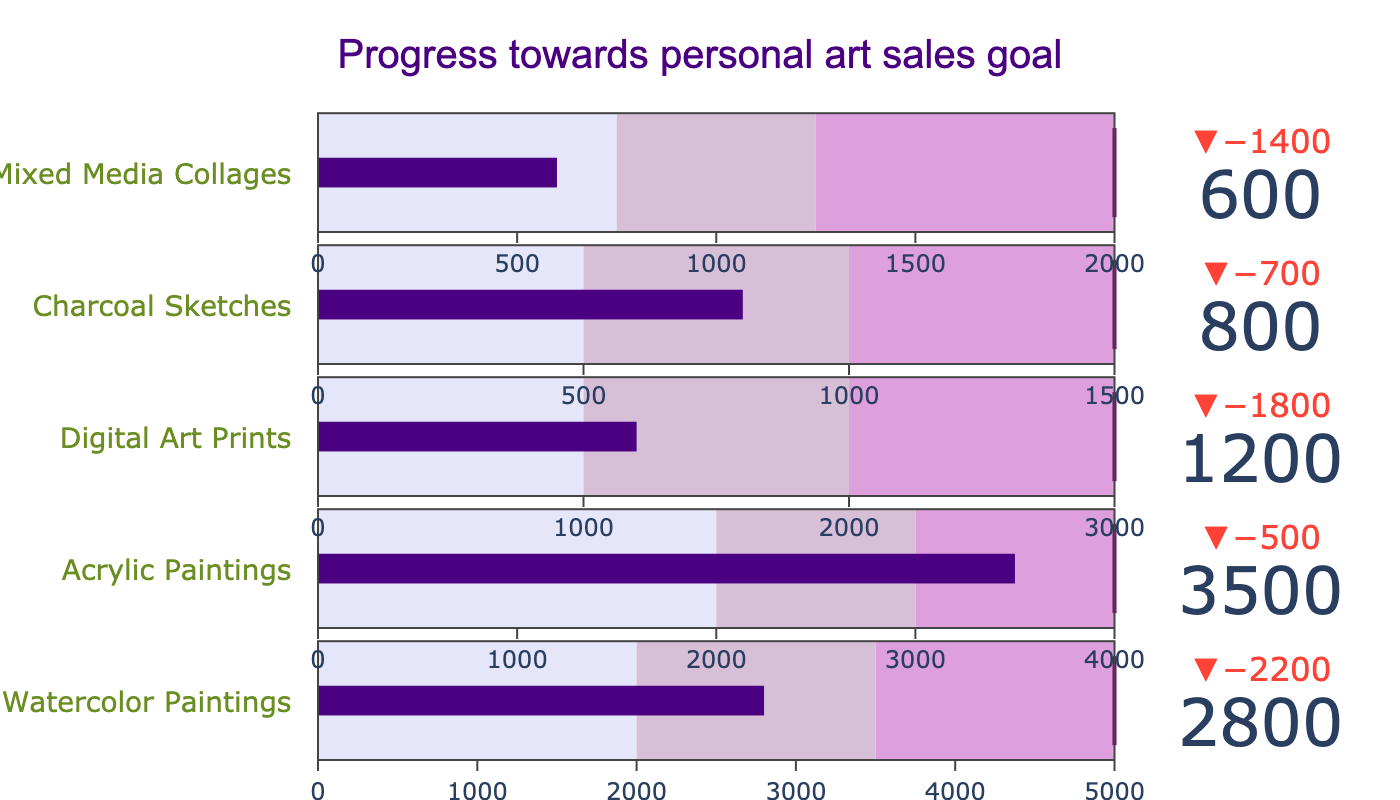How many types of art mediums are displayed in the figure? By observing the titles for each row, we can count the number of different art mediums listed in the chart.
Answer: 5 What is the title of the chart? The title of the chart is displayed at the top center of the figure.
Answer: Progress towards personal art sales goal Which art medium has the highest actual sales value? By comparing the actual sales values for each art medium, we see which one has the highest value.
Answer: Acrylic Paintings How much less are the Digital Art Prints' actual sales compared to their target? Subtract the actual sales value of Digital Art Prints from their target value (3000 - 1200).
Answer: 1800 Which art medium's actual sales are closest to its target? By comparing the deltas (difference between actual and target) for each art medium, we see which one has the smallest difference.
Answer: Acrylic Paintings What is the range of values the watercolor paintings fall into within their goal? Look at the gauge steps for Watercolor Paintings to find and describe the range it occupies (0 to 2800).
Answer: 2000 to 3500 Which art medium falls short the most in terms of percentage towards its goal? Calculate the percentage of the goal achieved for each art medium and compare them. Percentage achieved = (Actual/Target)*100.
Answer: Charcoal Sketches Is there any art medium that has exceeded the 'good' performance range but is still below the target? Compare the actual sales to the 'good' range and target for each medium to identify any that fit this condition; 'good' range is the second step color.
Answer: Charcoal Sketches Between Watercolor Paintings and Mixed Media Collages, which has a better percentage of its target achieved? Calculate the percentage of the target achieved for both and compare: Watercolor Paintings: (2800/5000)*100, Mixed Media Collages: (600/2000)*100.
Answer: Watercolor Paintings What is the axis limit for the 'target' performance range for Digital Art Prints? Look at the thresholds and axis range for Digital Art Prints to identify the upper limit of the range that marks the target.
Answer: 3000 